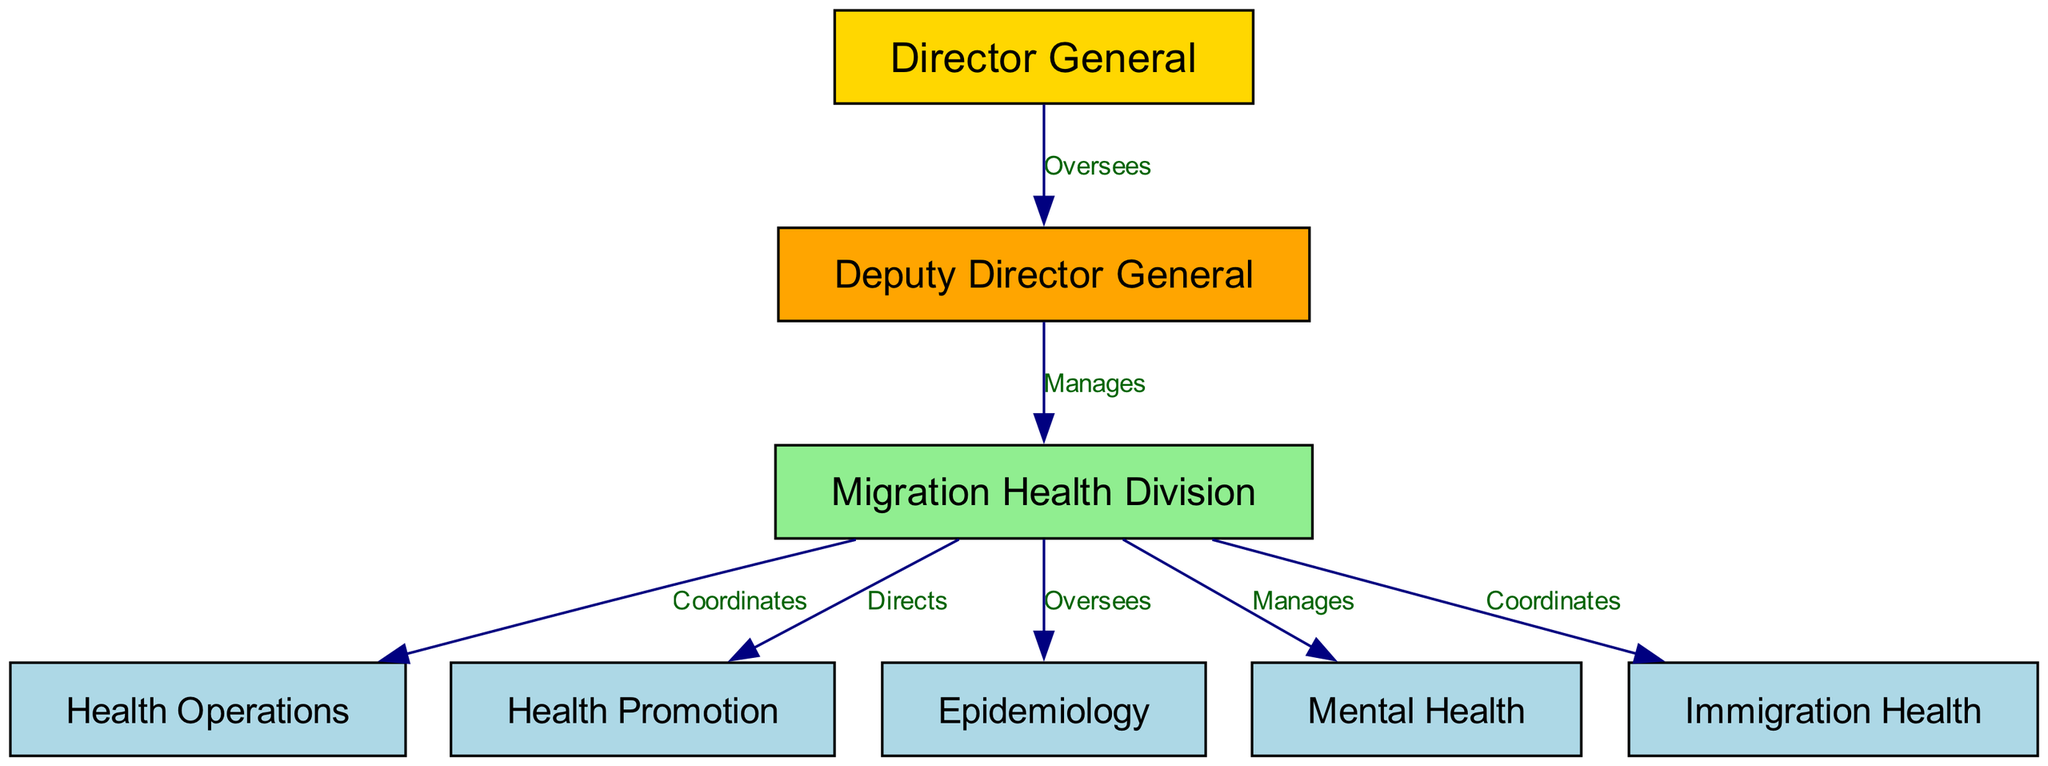What is the top layer in the organizational structure? The top layer in the diagram has the "Director General". This is evident as it is the only node that does not have any other node above it, indicating that it is at the highest level of the hierarchy.
Answer: Director General How many departments are under the Migration Health Division? The Migration Health Division has four departments directly connected to it: Health Operations, Health Promotion, Epidemiology, and Mental Health. By counting these nodes, we can ascertain the total number of departments.
Answer: Four Which department coordinates with Immigration Health? The diagram indicates that the Migration Health Division coordinates with the Immigration Health department. This relationship is denoted by the edge labeled "Coordinates" from the Migration Health Division to Immigration Health.
Answer: Immigration Health Who manages the Migration Health Division? The "Deputy Director General" manages the Migration Health Division, as shown by the edge labeled "Manages" pointing from the Deputy Director General to the Migration Health Division.
Answer: Deputy Director General What relationship does the Deputy Director General have with the Director General? The relationship is labeled as "Oversees", indicating that the Deputy Director General is under the guidance or supervision of the Director General. This is confirmed by the directed edge connecting these two nodes.
Answer: Oversees Which department is specifically focused on mental health? The diagram identifies "Mental Health" as the department specifically focused on mental health, which is a standalone node under the Migration Health Division.
Answer: Mental Health What is the role of Health Promotion in the organizational structure? "Health Promotion" is directed by the Migration Health Division, which means the Migration Health Division has a supervisory role over this department, showing a direct hierarchical relationship between them.
Answer: Directs Does the Health Operations department report to the Director General? No, the Health Operations department does not report directly to the Director General. Instead, it reports to the Migration Health Division, which is under the Deputy Director General. Therefore, the chain of command does not include a direct reporting line to the Director General.
Answer: No How many edges are there in the diagram? The diagram contains six edges that define the relationships between nodes. By counting the edges listed in the data section, we find that the total number of connections is six.
Answer: Six 